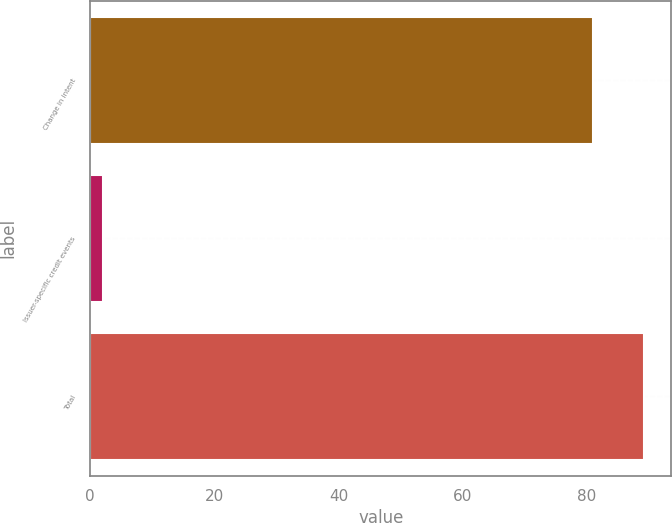Convert chart to OTSL. <chart><loc_0><loc_0><loc_500><loc_500><bar_chart><fcel>Change in intent<fcel>Issuer-specific credit events<fcel>Total<nl><fcel>81<fcel>2<fcel>89.1<nl></chart> 